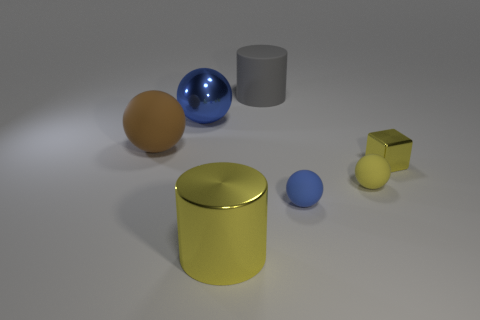Subtract all matte balls. How many balls are left? 1 Subtract all brown balls. How many balls are left? 3 Subtract all red spheres. Subtract all purple blocks. How many spheres are left? 4 Add 3 big rubber cylinders. How many objects exist? 10 Subtract all cubes. How many objects are left? 6 Add 1 yellow rubber objects. How many yellow rubber objects are left? 2 Add 7 small green metal blocks. How many small green metal blocks exist? 7 Subtract 0 brown cubes. How many objects are left? 7 Subtract all large yellow objects. Subtract all big blue metal objects. How many objects are left? 5 